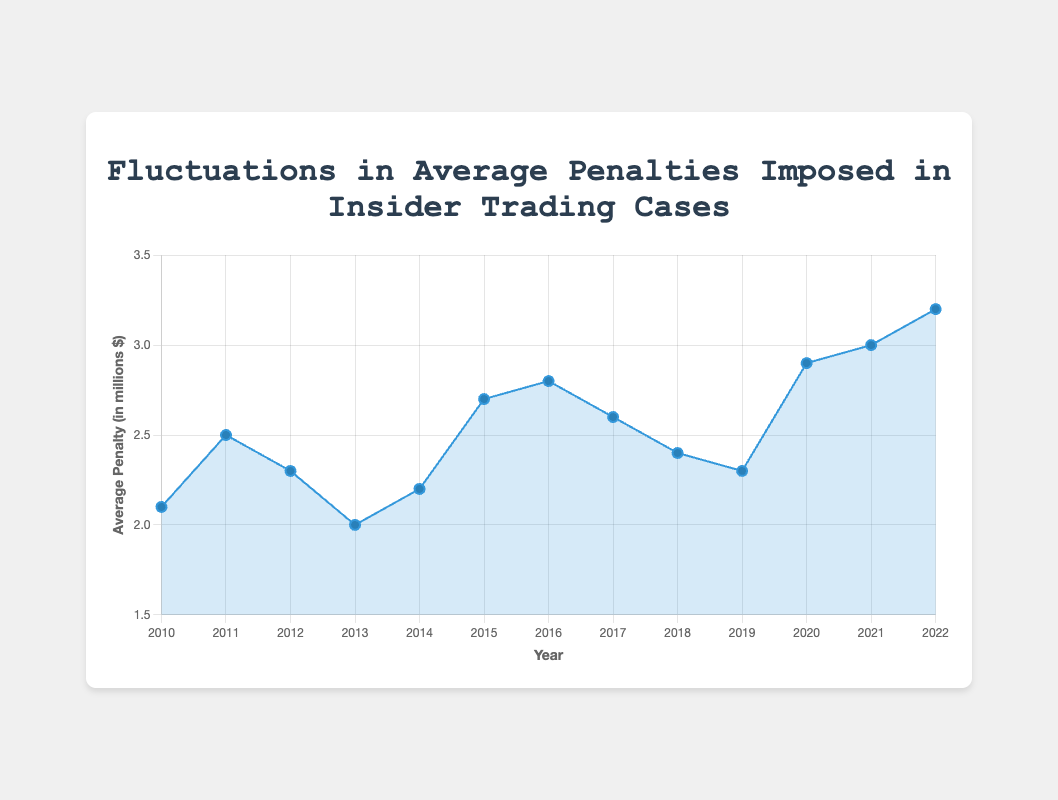what is the overall trend in the average penalty from 2010 to 2022? Observing the plotted line from 2010 to 2022, there is a general upward trend in the average penalty, starting from 2.1 million dollars in 2010 and increasing to 3.2 million dollars in 2022.
Answer: Upward which year had the highest average penalty, and what was the penalty? By glancing at the peak of the line graph, the highest average penalty occurred in 2022 with a value of 3.2 million dollars.
Answer: 2022, 3.2 million dollars between which years did the average penalty see the largest increase? The largest increase occurred between 2019 and 2020, where penalties rose from 2.3 to 2.9 million dollars, marking an increase of 0.6 million dollars.
Answer: 2019-2020 in which year did the average penalty show the largest decrease, and by how much? The largest decrease happened between 2011 and 2012, where the penalty dropped from 2.5 to 2.3 million dollars, a decrease of 0.2 million dollars.
Answer: 2011-2012, 0.2 million dollars how many years had an average penalty greater than 2.5 million dollars? From the visual chart, the average penalty was greater than 2.5 million dollars in 2015, 2016, 2017, 2020, 2021, and 2022. That's 6 years.
Answer: 6 in which years were the average penalties exactly equal to 2.3 million dollars? From the chart, 2012 and 2019 had average penalties exactly equal to 2.3 million dollars.
Answer: 2012, 2019 what was the average of the average penalties from 2010 to 2015? Adding the penalties from 2010 to 2015: 2.1 (2010) + 2.5 (2011) + 2.3 (2012) + 2.0 (2013) + 2.2 (2014) + 2.7 (2015) gives 13.8. Dividing by the 6 years, the average is 13.8/6 = 2.3 million dollars.
Answer: 2.3 million dollars which year had a notable case associated with "Michael Steinberg", and what was the average penalty that year? From the tooltip information, 2013 had the notable case of Michael Steinberg, with an average penalty of 2.0 million dollars.
Answer: 2013, 2.0 million dollars compare the average penalties between 2015 and 2022. Which is greater and by how much? The average penalty in 2015 was 2.7 million dollars, while in 2022 it was 3.2 million dollars. The penalty in 2022 is greater by 0.5 million dollars.
Answer: 2022, 0.5 million dollars what is the range of the average penalties from 2010 to 2022? The range is calculated by subtracting the smallest value from the largest value. The smallest is 2.0 million dollars (2013) and the largest is 3.2 million dollars (2022). The range is 3.2 - 2.0 = 1.2 million dollars.
Answer: 1.2 million dollars 